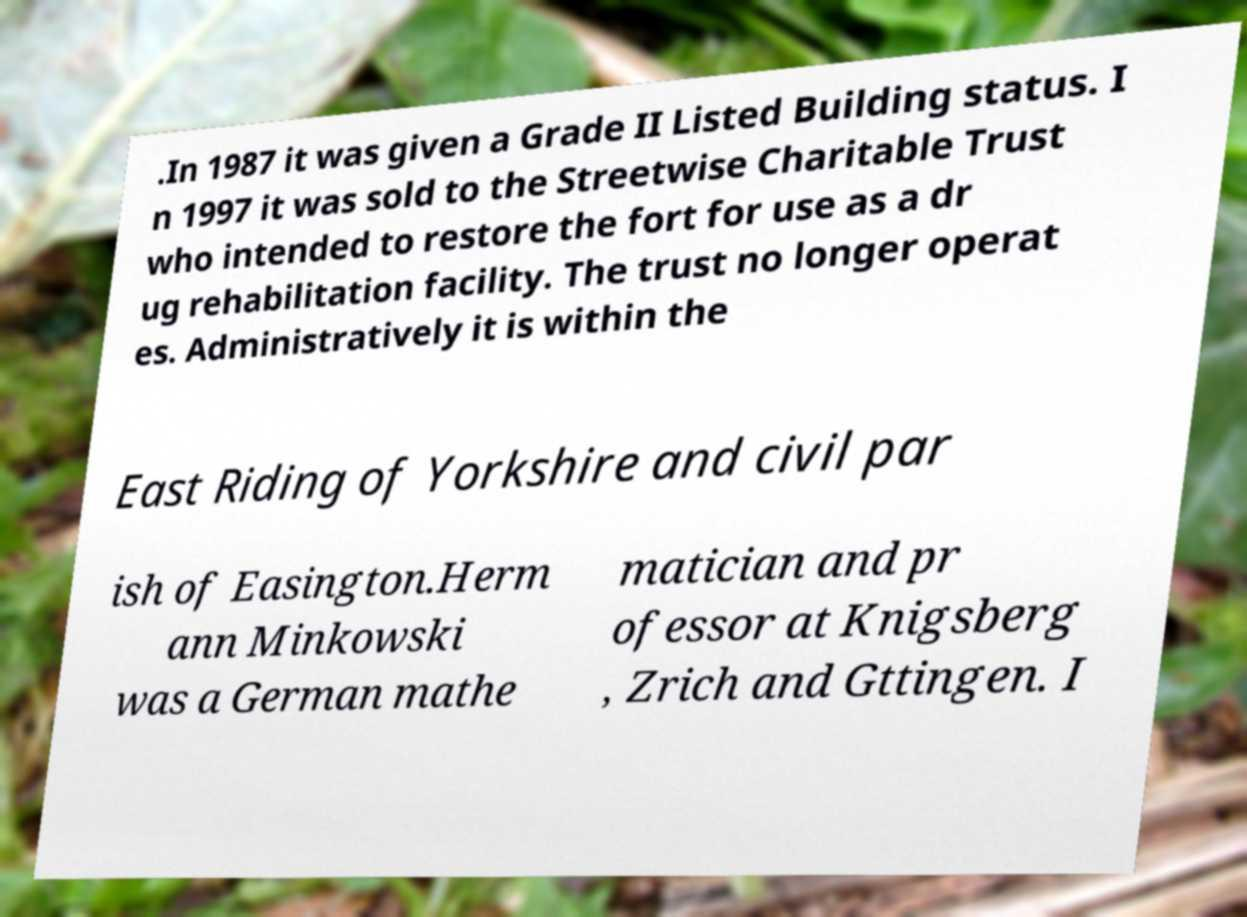I need the written content from this picture converted into text. Can you do that? .In 1987 it was given a Grade II Listed Building status. I n 1997 it was sold to the Streetwise Charitable Trust who intended to restore the fort for use as a dr ug rehabilitation facility. The trust no longer operat es. Administratively it is within the East Riding of Yorkshire and civil par ish of Easington.Herm ann Minkowski was a German mathe matician and pr ofessor at Knigsberg , Zrich and Gttingen. I 